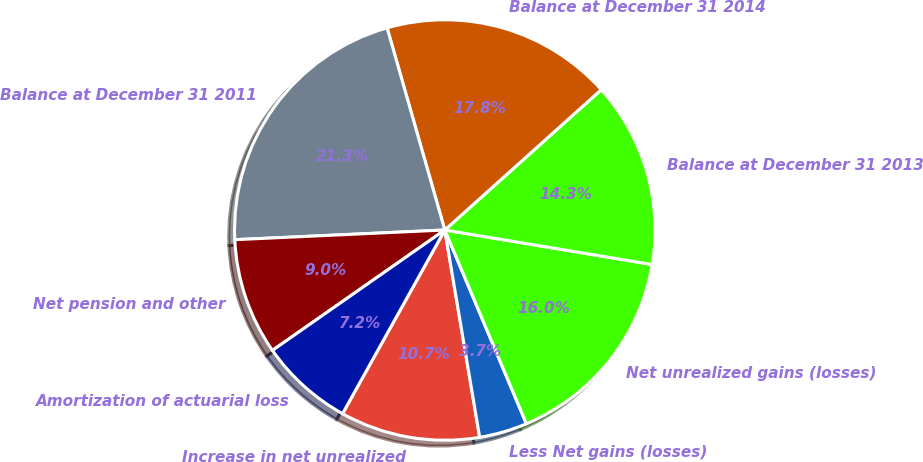Convert chart to OTSL. <chart><loc_0><loc_0><loc_500><loc_500><pie_chart><fcel>Increase in net unrealized<fcel>Less Net gains (losses)<fcel>Net unrealized gains (losses)<fcel>Balance at December 31 2013<fcel>Balance at December 31 2014<fcel>Balance at December 31 2011<fcel>Net pension and other<fcel>Amortization of actuarial loss<nl><fcel>10.74%<fcel>3.69%<fcel>16.03%<fcel>14.26%<fcel>17.79%<fcel>21.31%<fcel>8.97%<fcel>7.21%<nl></chart> 